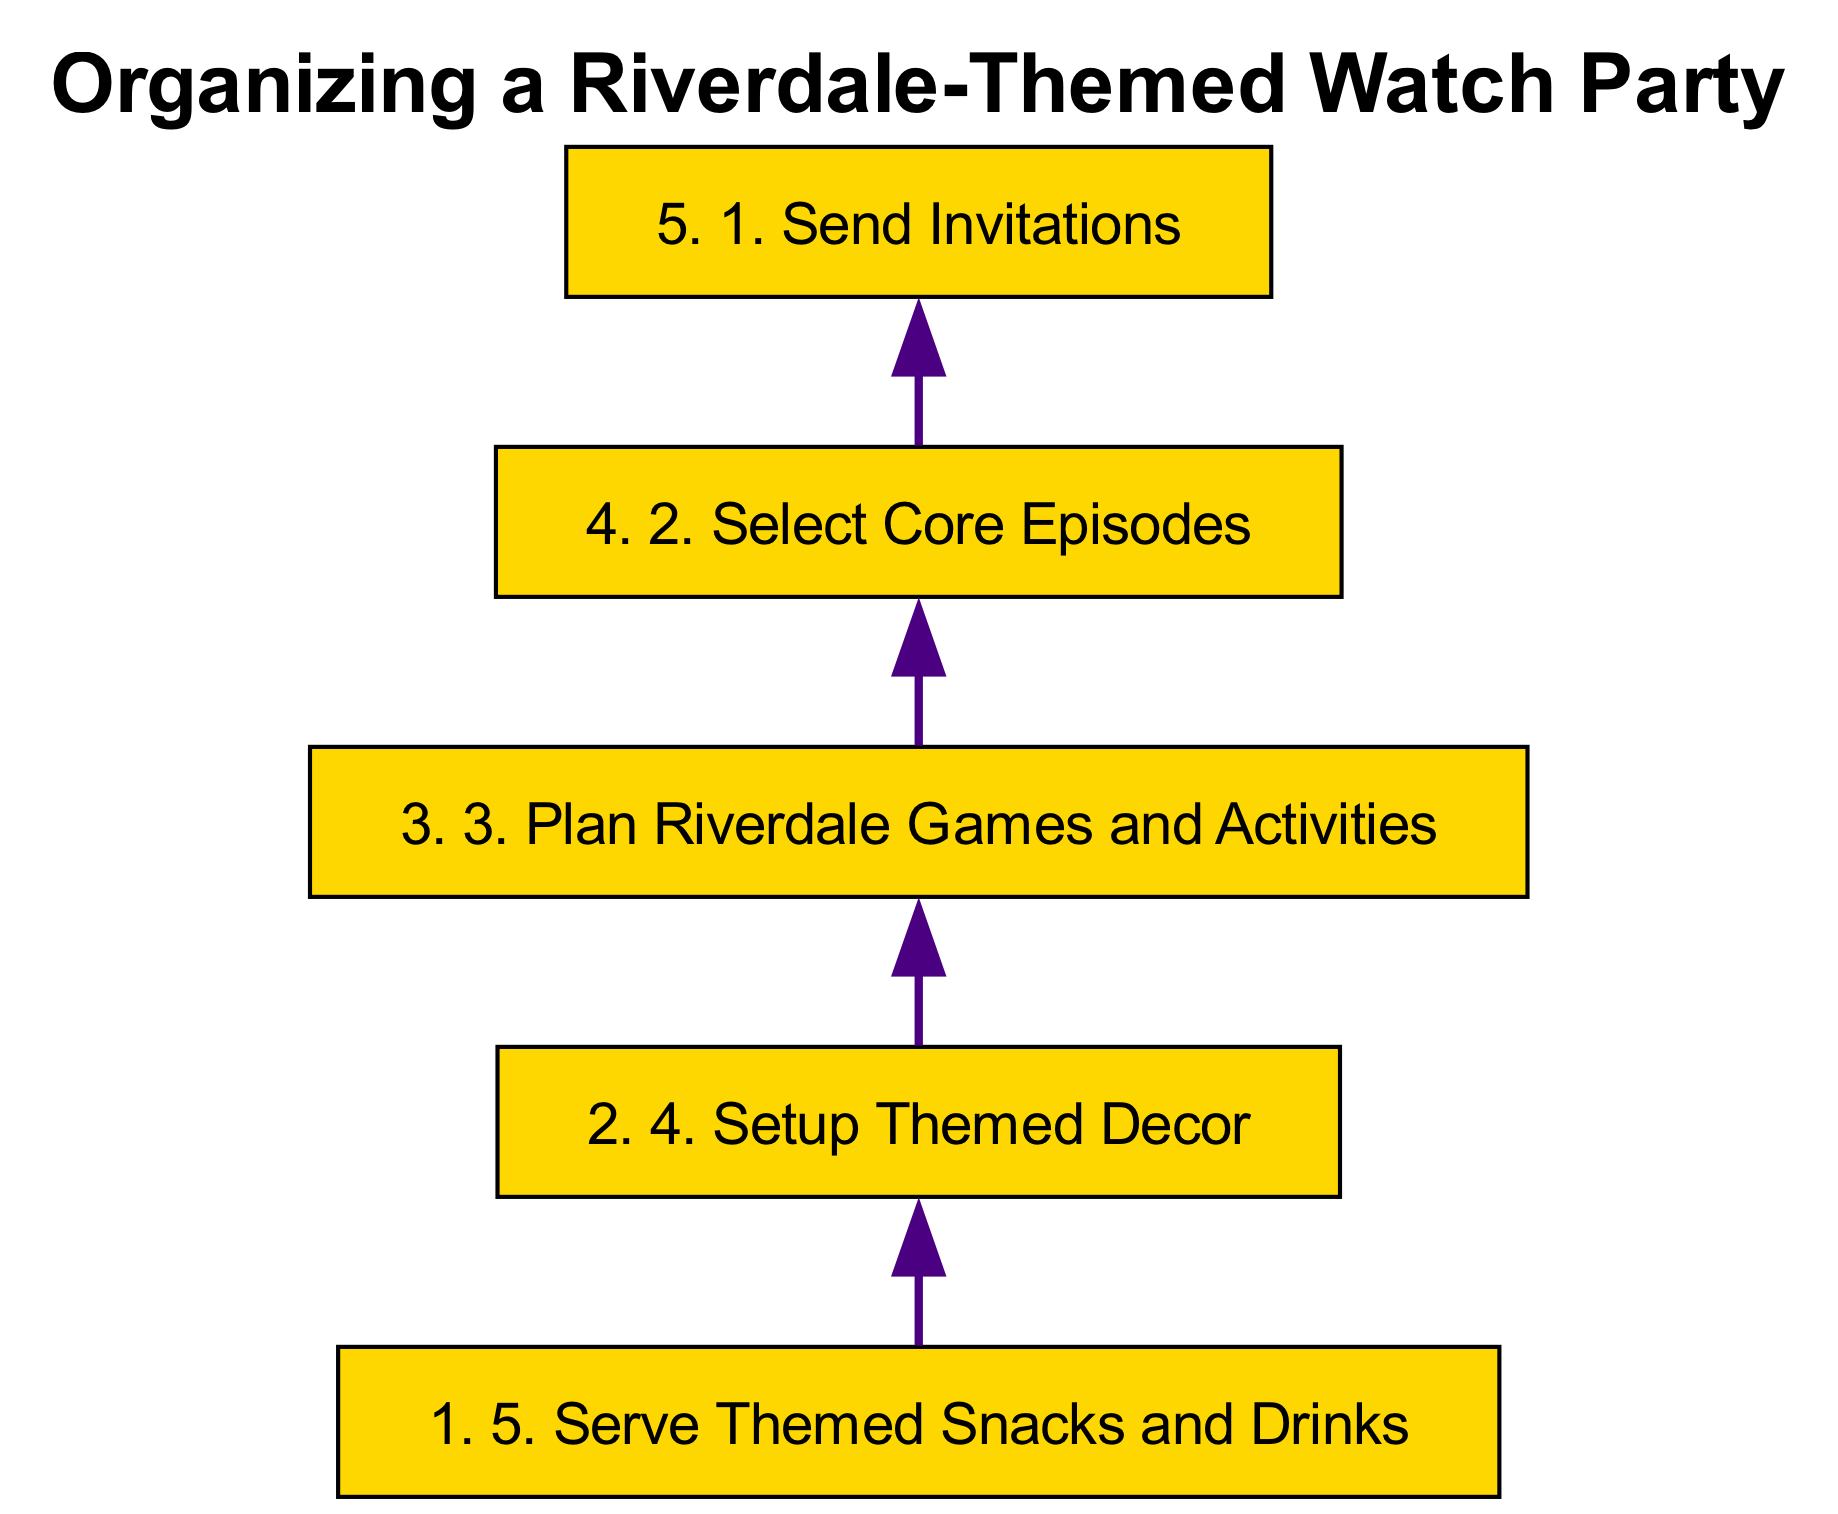What is the first step in organizing the watch party? The diagram lists the first step as "Send Invitations," which is represented at the bottom of the flow chart.
Answer: Send Invitations How many total steps are in the process? There are five steps detailed in the flow chart, which can be counted from the list in the diagram.
Answer: 5 What themed decor is suggested in step four? In step four, the decor mentioned includes items like Jughead's beanie replicas, Riverdale High banners, and 'The Whyte Wyrm' posters, which are directly associated with the Riverdale theme.
Answer: Jughead's beanie replicas, Riverdale High banners, 'The Whyte Wyrm' posters Which step comes directly after selecting core episodes? The flow chart indicates that the step following "Select Core Episodes" is "Plan Riverdale Games and Activities," as this is the sequence of the nodes listed in the diagram.
Answer: Plan Riverdale Games and Activities What type of activities are suggested in the third step? The third step outlines organizing activities such as Riverdale trivia games, a 'Bughead' quiz, and a costume contest, which are all fun components of the event based on the diagram.
Answer: Riverdale trivia games, 'Bughead' quiz, costume contest What is the tooltip for the final step? The tooltip for "Serve Themed Snacks and Drinks" details specific food items like 'Pop's Chock'lit Shoppe' milkshakes, Southside Serpents sliders, and Blossom Maple Syrup cookies, as indicated in the flow chart.
Answer: Prepare snacks and drinks inspired by the show How is the watch party's theme reflected in the snacks? In step five, the snacks are said to be inspired by the show, indicating that the themed snacks like milkshakes and cookies relate to specific elements from Riverdale.
Answer: Inspired by the show Which step is linked directly to serving snacks and drinks? The diagram’s directed flow shows that "Serve Themed Snacks and Drinks" is the topmost step, indicating it has no further links above it.
Answer: None (it's the top step) 